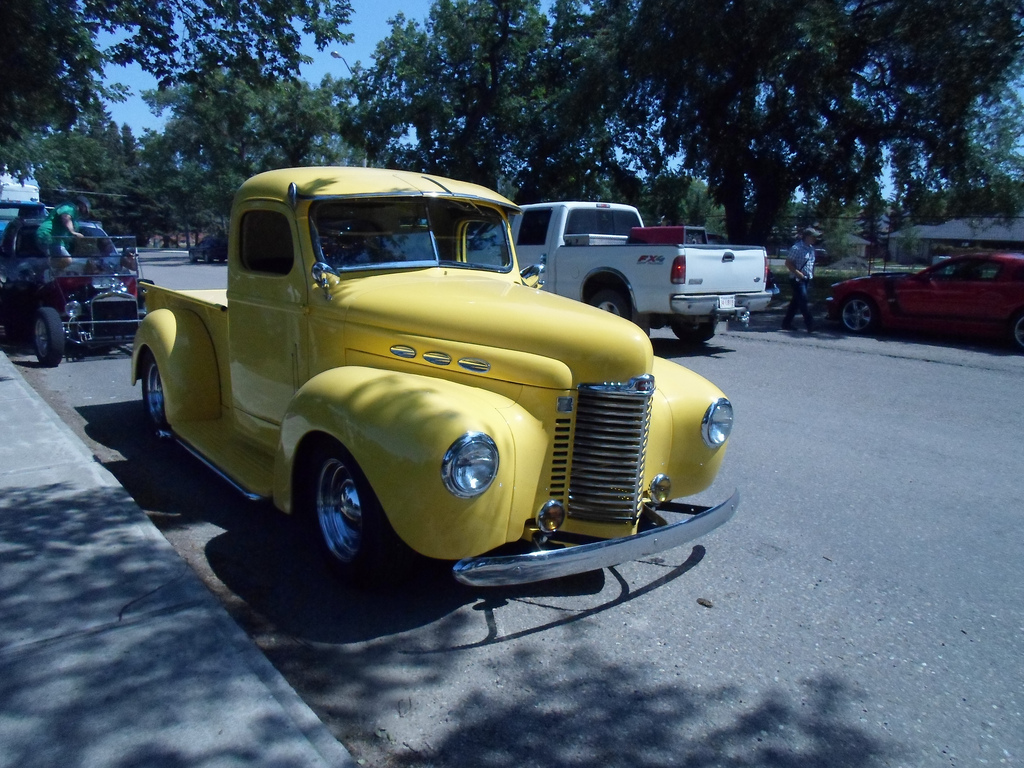Where was the picture taken? The picture was taken on a tree-lined street during a sunny day, at a local car show showcasing vintage cars, based on the background and the vehicles displayed. 